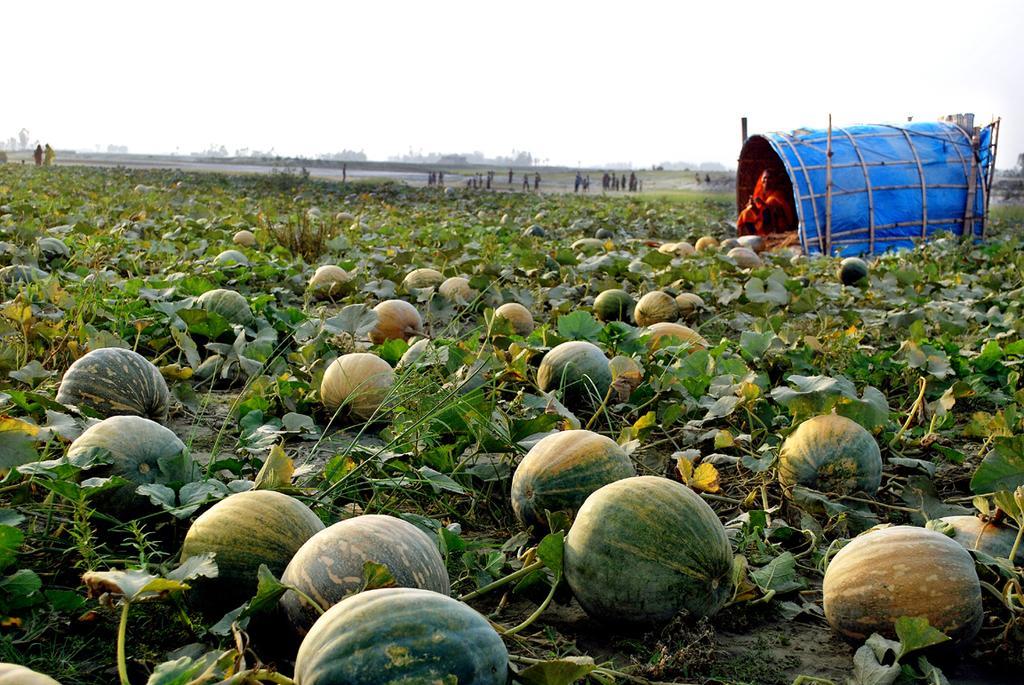Please provide a concise description of this image. In this picture, we see the pumpkin field. On the right side, it looks like a wooden hut which is covered with a blue color sheet. We see a woman is sitting. We see the people are standing. There are trees in the background. At the top, we see the sky. 